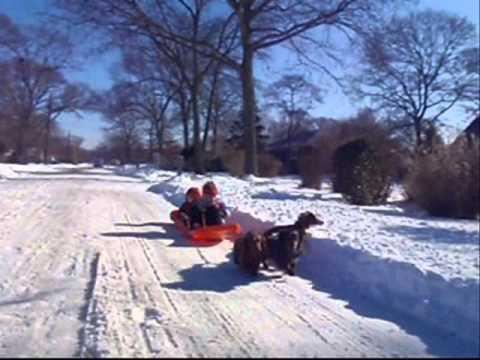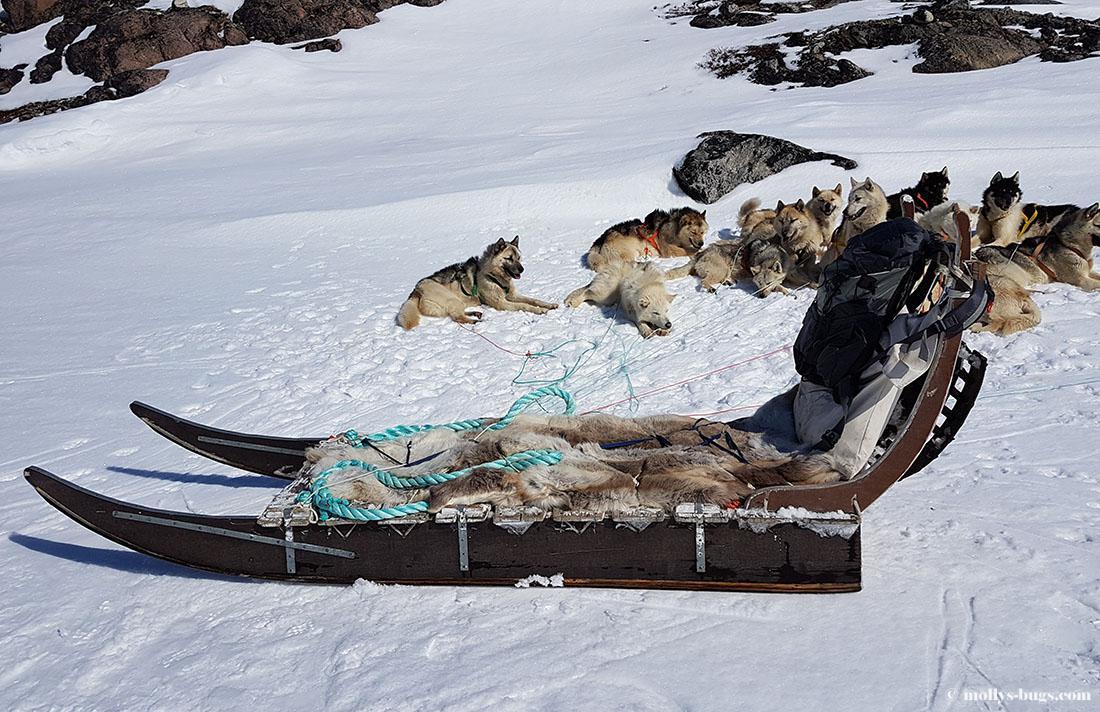The first image is the image on the left, the second image is the image on the right. For the images shown, is this caption "The image on the left has a person using a red sled." true? Answer yes or no. Yes. The first image is the image on the left, the second image is the image on the right. Assess this claim about the two images: "An image shows a sled pulled by two dogs, heading downward and leftward.". Correct or not? Answer yes or no. No. 